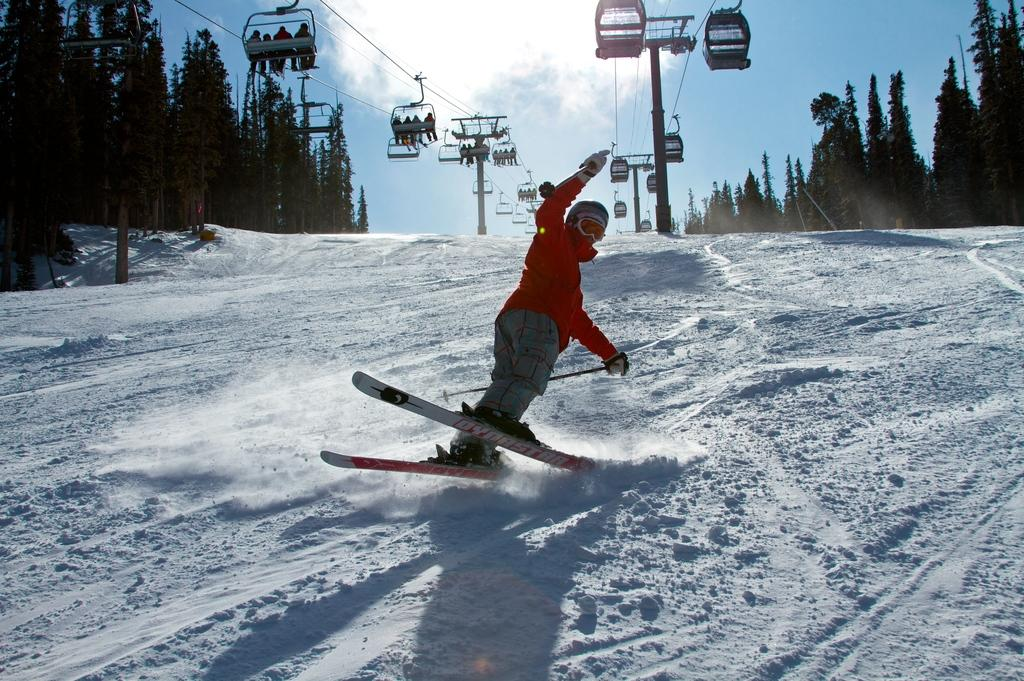What is the person in the image holding? The person in the image is holding ski-boards and ski-poles. What are the other people in the image doing? There is a group of people riding the rope-way in the image. What type of vegetation can be seen in the image? There are trees in the image. What is the ground covered with in the image? There is snow in the image. What can be seen in the background of the image? The sky is visible in the background of the image. What type of calculator is the person using while skiing in the image? There is no calculator present in the image; the person is holding ski-boards and ski-poles. What kind of bean is visible in the image? There are no beans present in the image; it features a person skiing and a group of people riding the rope-way in a snowy environment. 